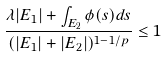<formula> <loc_0><loc_0><loc_500><loc_500>\frac { \lambda | E _ { 1 } | + \int _ { E _ { 2 } } \phi ( s ) d s } { ( | E _ { 1 } | + | E _ { 2 } | ) ^ { 1 - 1 / p } } \leq 1</formula> 